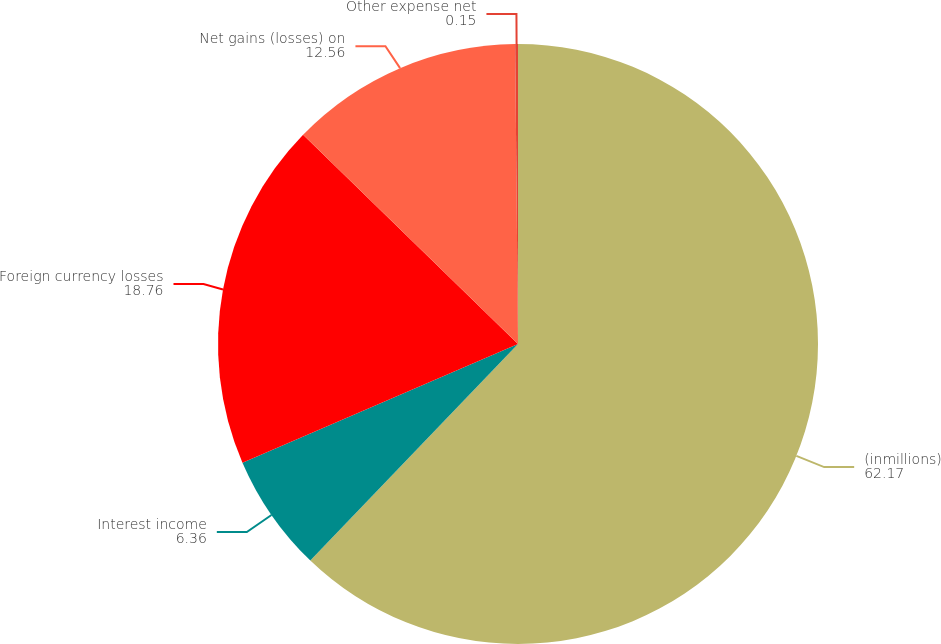<chart> <loc_0><loc_0><loc_500><loc_500><pie_chart><fcel>(inmillions)<fcel>Interest income<fcel>Foreign currency losses<fcel>Net gains (losses) on<fcel>Other expense net<nl><fcel>62.17%<fcel>6.36%<fcel>18.76%<fcel>12.56%<fcel>0.15%<nl></chart> 